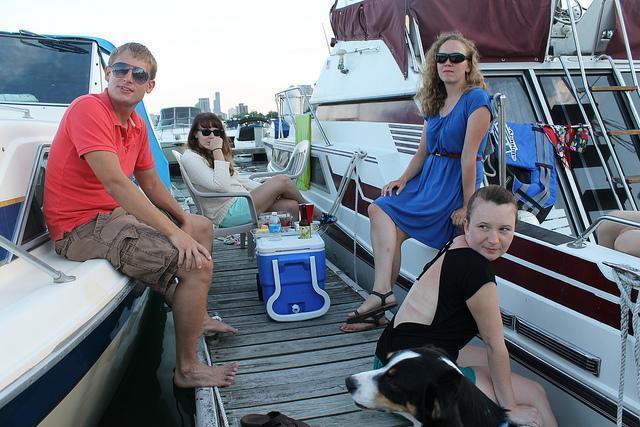Clothing items are hung here for which purpose?
Make your selection from the four choices given to correctly answer the question.
Options: Warning, signaling, drying, sale display. Drying. 